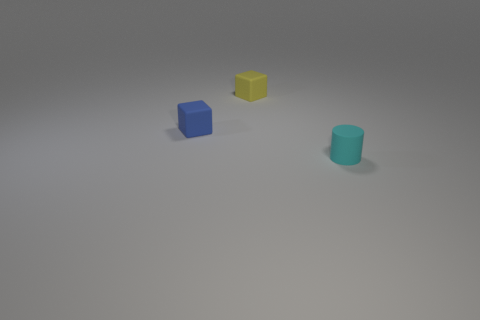Subtract all yellow cubes. How many cubes are left? 1 Add 3 tiny cyan things. How many objects exist? 6 Subtract all cubes. How many objects are left? 1 Add 3 blue rubber objects. How many blue rubber objects are left? 4 Add 3 tiny brown rubber cubes. How many tiny brown rubber cubes exist? 3 Subtract 1 cyan cylinders. How many objects are left? 2 Subtract all yellow cylinders. Subtract all blue spheres. How many cylinders are left? 1 Subtract all cyan rubber cylinders. Subtract all big green rubber cylinders. How many objects are left? 2 